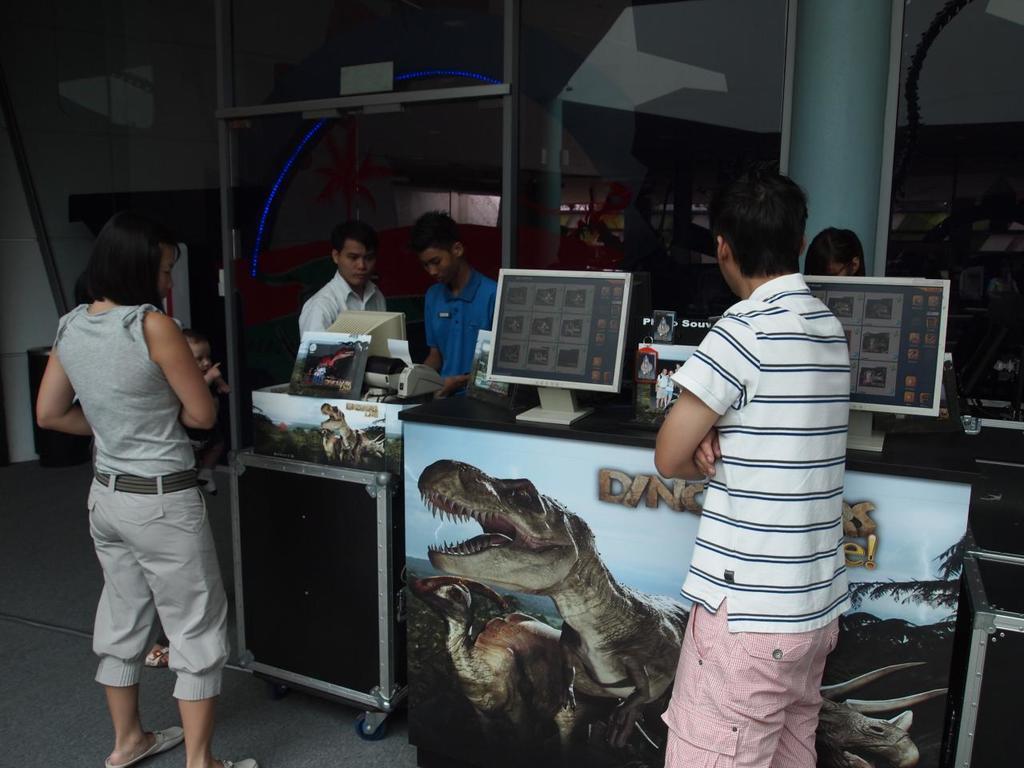Please provide a concise description of this image. In this picture I can observe some people standing on the floor. I can observe two monitors placed on the desk. In the background I can observe wall. 